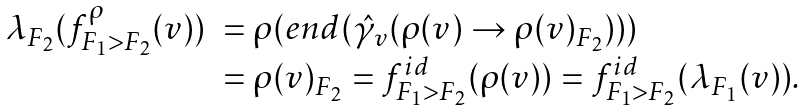<formula> <loc_0><loc_0><loc_500><loc_500>\begin{array} { r l } \lambda _ { F _ { 2 } } ( f ^ { \rho } _ { F _ { 1 } > F _ { 2 } } ( v ) ) & = \rho ( e n d ( \hat { \gamma } _ { v } ( \rho ( v ) \rightarrow \rho ( v ) _ { F _ { 2 } } ) ) ) \\ & = \rho ( v ) _ { F _ { 2 } } = f ^ { i d } _ { F _ { 1 } > F _ { 2 } } ( \rho ( v ) ) = f ^ { i d } _ { F _ { 1 } > F _ { 2 } } ( \lambda _ { F _ { 1 } } ( v ) ) . \end{array}</formula> 